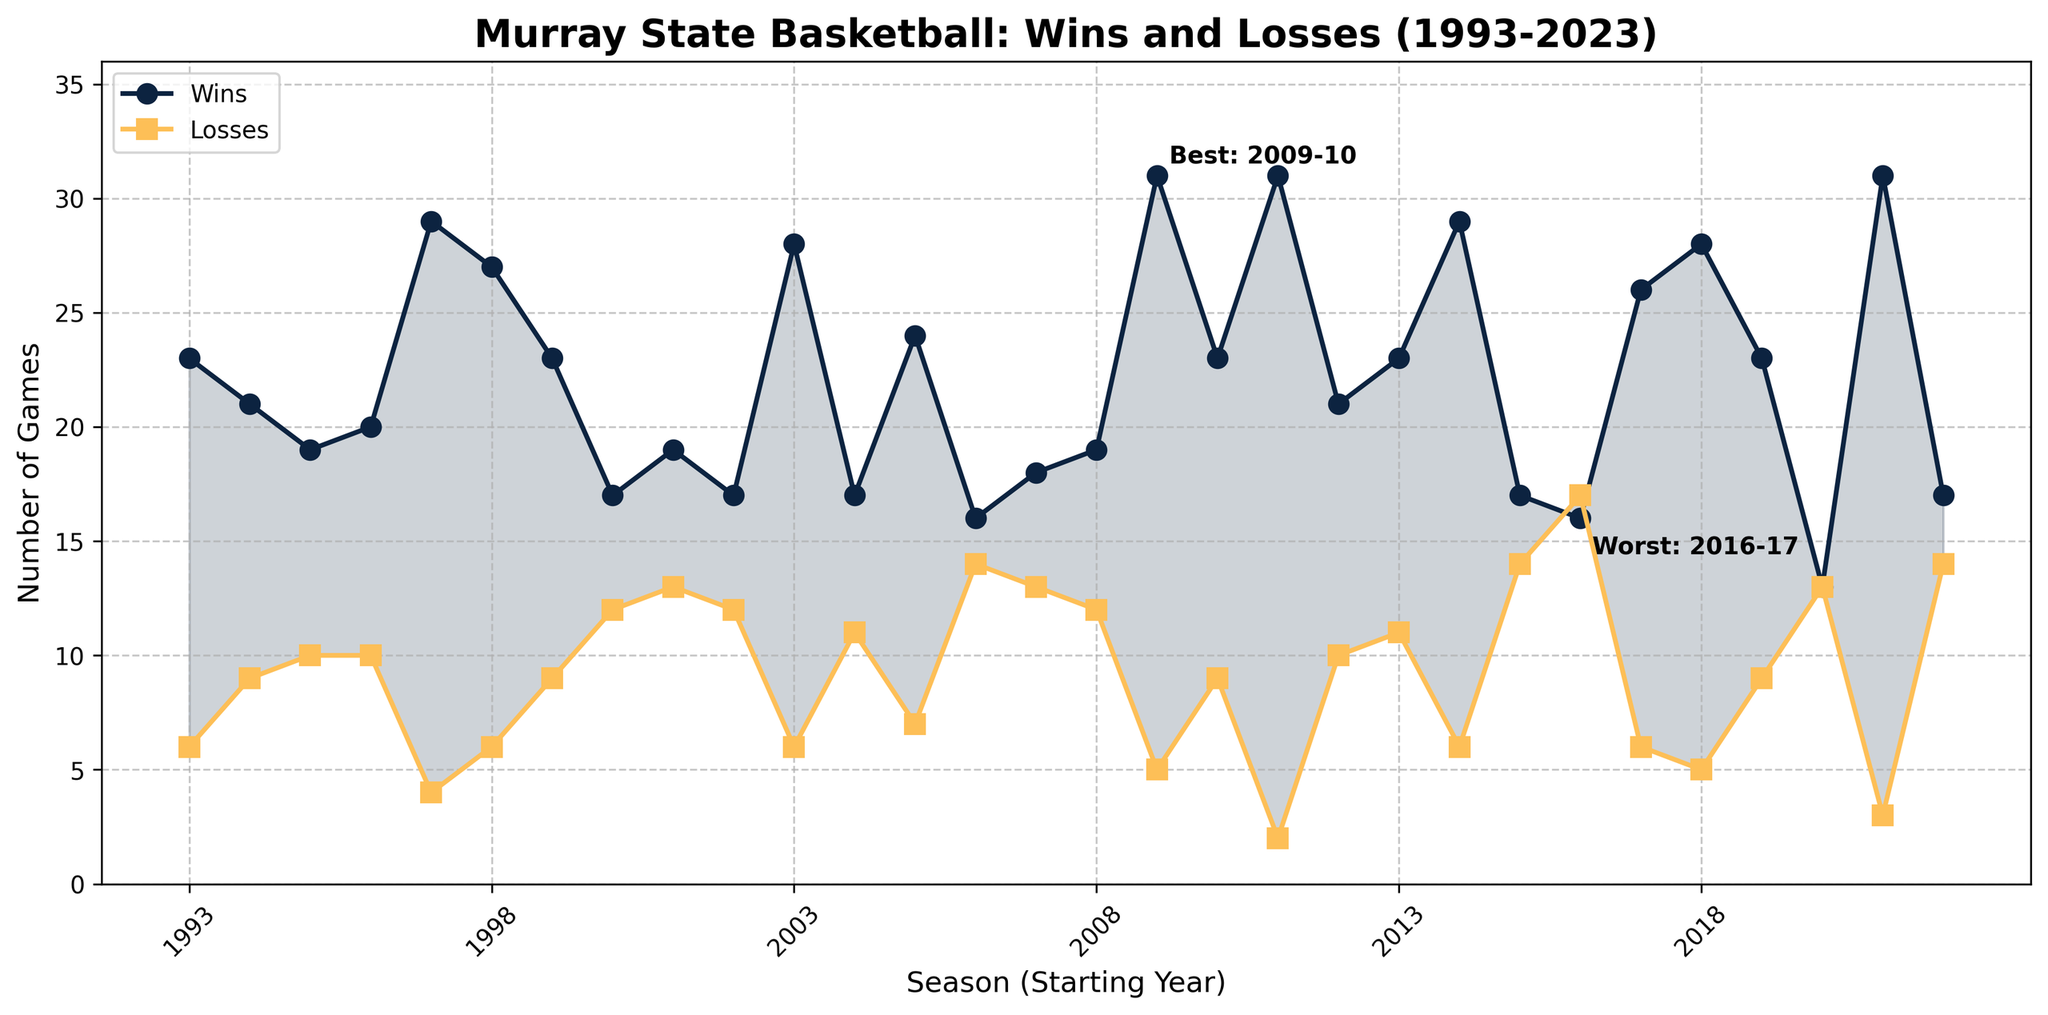What is the best season in terms of wins for Murray State basketball? The best season can be identified by looking at the highest point on the "Wins" line. According to the plot, the season with the highest number of wins is 2011-12 with 31 wins.
Answer: 2011-12 Which season had the highest number of losses? The season with the highest number of losses can be found by looking at the highest point on the "Losses" line. The plot shows that the 2016-17 season had the highest number of losses, at 17.
Answer: 2016-17 During which season did the team achieve more wins than the average number of wins across all seasons? First, calculate the average number of wins by summing the wins and dividing by the number of seasons. Then identify the seasons where the wins exceed this average from the plot. The sum of wins is 614, and with 30 seasons, the average number of wins is 614/30 ≈ 20.47. Seasons with wins greater than this value are evident from the plot: 1993-94, 1994-95, 1996-97, 1997-98, 1998-99, 1999-00, 2003-04, 2005-06, 2009-10, 2010-11, 2011-12, 2012-13, 2013-14, 2014-15, 2017-18, 2018-19, 2019-20, and 2021-22.
Answer: multiple seasons How many times did the team achieve more than 25 wins in a season? Count the peaks of the "Wins" line that are above 25. According to the plot, these seasons are 1997-98, 1998-99, 2003-04, 2005-06, 2009-10, 2011-12, 2014-15, 2017-18, 2018-19, and 2021-22. There are 10 such seasons.
Answer: 10 Identify the season with the biggest win-loss difference. What is the difference? To find the biggest win-loss difference, calculate the differences for all seasons and identify the largest one. The peak differences according to the plot seem to be during the 2009-10 and 2011-12 seasons. For 2009-10: 31 - 5 = 26; for 2011-12: 31 - 2 = 29. So, 2011-12 has the biggest difference with 29.
Answer: 2011-12, 29 What trend can be observed in losses during the 2000-2005 period? Look at the "Losses" line between the 2000 and 2005 seasons. The number of losses starts around 12 in 2000-01, then fluctuates slightly before increasing in 2001-02 (13), dropping again to 11-12 from 2002-2005. The trend is relatively stable with minor fluctuations.
Answer: stable with minor fluctuations How many seasons did the team end with an equal number of wins and losses? Check the seasons where the "Wins" and "Losses" lines intersect. According to the plot, this scenario occurs in the 2020-21 season (13 wins and 13 losses).
Answer: 1 Does the plot show more high-winning seasons towards the beginning, middle, or end? Determine the frequency of peak wins in the respective periods: early (1993-2002), middle (2003-2012), and recent (2013-2023). Peaks are slightly more frequent towards the end (e.g., 2011-12, 2014-15, 2017-18, 2018-19, 2021-22).
Answer: towards the end 